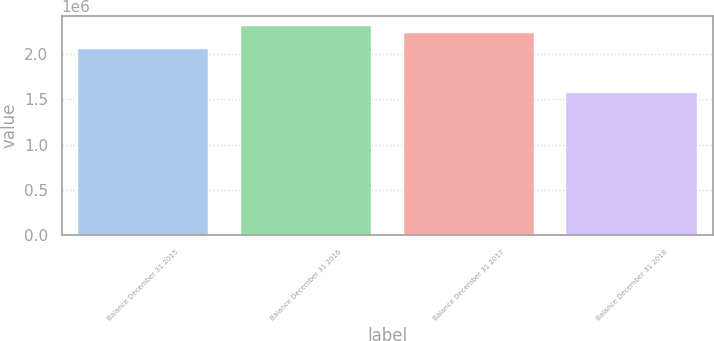<chart> <loc_0><loc_0><loc_500><loc_500><bar_chart><fcel>Balance December 31 2015<fcel>Balance December 31 2016<fcel>Balance December 31 2017<fcel>Balance December 31 2018<nl><fcel>2.05885e+06<fcel>2.30726e+06<fcel>2.23379e+06<fcel>1.56726e+06<nl></chart> 